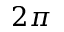<formula> <loc_0><loc_0><loc_500><loc_500>2 \pi</formula> 